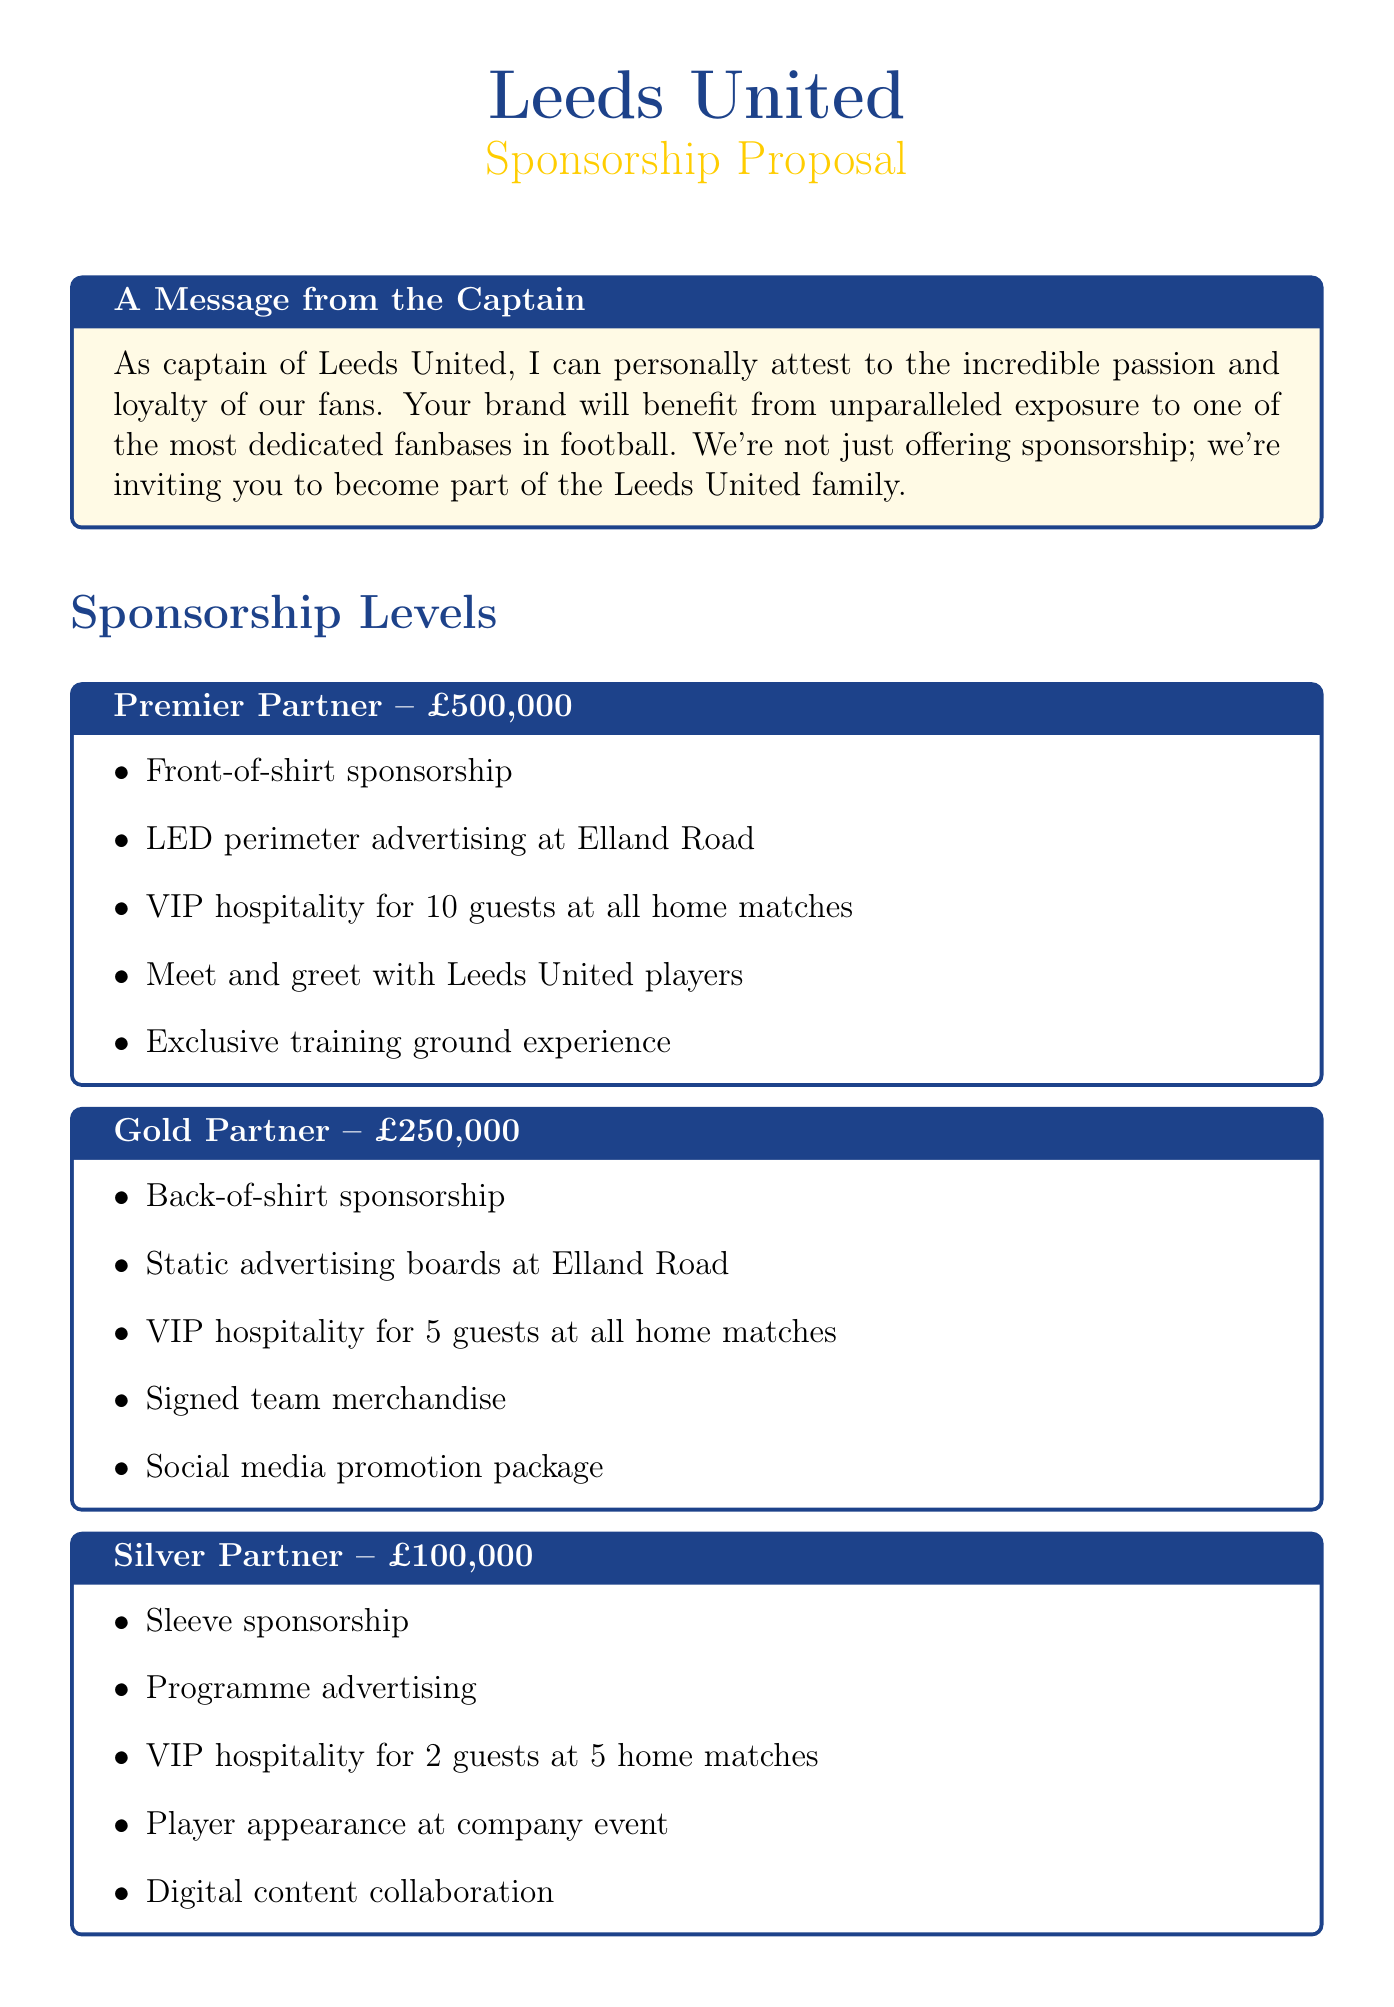What is the cost of becoming a Premier Partner? The document states that the cost for a Premier Partner is £500,000.
Answer: £500,000 What is one of the benefits of the Gold Partner level? The document mentions multiple benefits, one of which is back-of-shirt sponsorship.
Answer: Back-of-shirt sponsorship How many unique visitors does the website receive per month? The document specifies that the website traffic amounts to 5 million unique visitors each month.
Answer: 5 million Who is the Head of Commercial Partnerships? The document provides the name of the Head of Commercial Partnerships as Sarah Thompson.
Answer: Sarah Thompson What is the submission deadline for the sponsorship proposal? According to the document, the submission deadline is July 31, 2023.
Answer: July 31, 2023 How many VIP guests can a Premier Partner bring to home matches? The document states that a Premier Partner can bring 10 guests to all home matches.
Answer: 10 What type of advertising is included in the Silver Partner benefits? One of the benefits for a Silver Partner includes programme advertising.
Answer: Programme advertising What is the average attendance per match? The document indicates that the average attendance per match is 36,000.
Answer: 36,000 What is one marketing opportunity mentioned in the document? The document lists several marketing opportunities, including match day activation at Elland Road.
Answer: Match day activation at Elland Road 